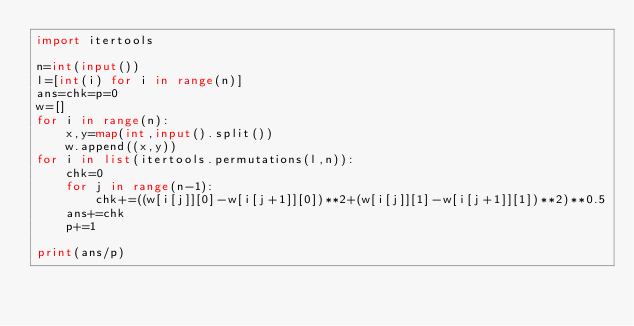Convert code to text. <code><loc_0><loc_0><loc_500><loc_500><_Python_>import itertools

n=int(input())
l=[int(i) for i in range(n)]
ans=chk=p=0
w=[]
for i in range(n):
    x,y=map(int,input().split())
    w.append((x,y))
for i in list(itertools.permutations(l,n)):
    chk=0
    for j in range(n-1):
        chk+=((w[i[j]][0]-w[i[j+1]][0])**2+(w[i[j]][1]-w[i[j+1]][1])**2)**0.5
    ans+=chk
    p+=1

print(ans/p)</code> 